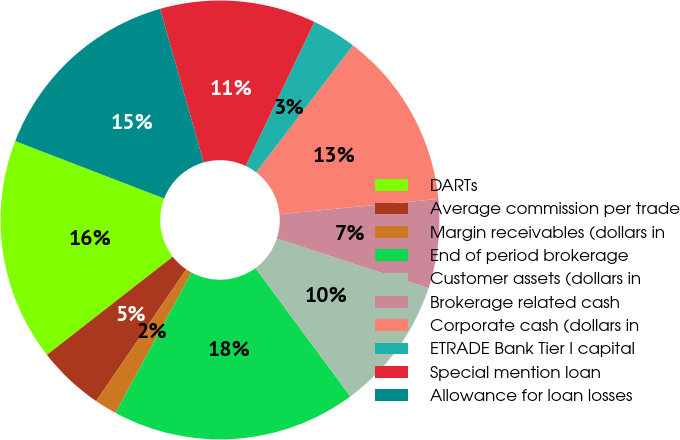Convert chart to OTSL. <chart><loc_0><loc_0><loc_500><loc_500><pie_chart><fcel>DARTs<fcel>Average commission per trade<fcel>Margin receivables (dollars in<fcel>End of period brokerage<fcel>Customer assets (dollars in<fcel>Brokerage related cash<fcel>Corporate cash (dollars in<fcel>ETRADE Bank Tier I capital<fcel>Special mention loan<fcel>Allowance for loan losses<nl><fcel>16.39%<fcel>4.92%<fcel>1.64%<fcel>18.03%<fcel>9.84%<fcel>6.56%<fcel>13.11%<fcel>3.28%<fcel>11.48%<fcel>14.75%<nl></chart> 